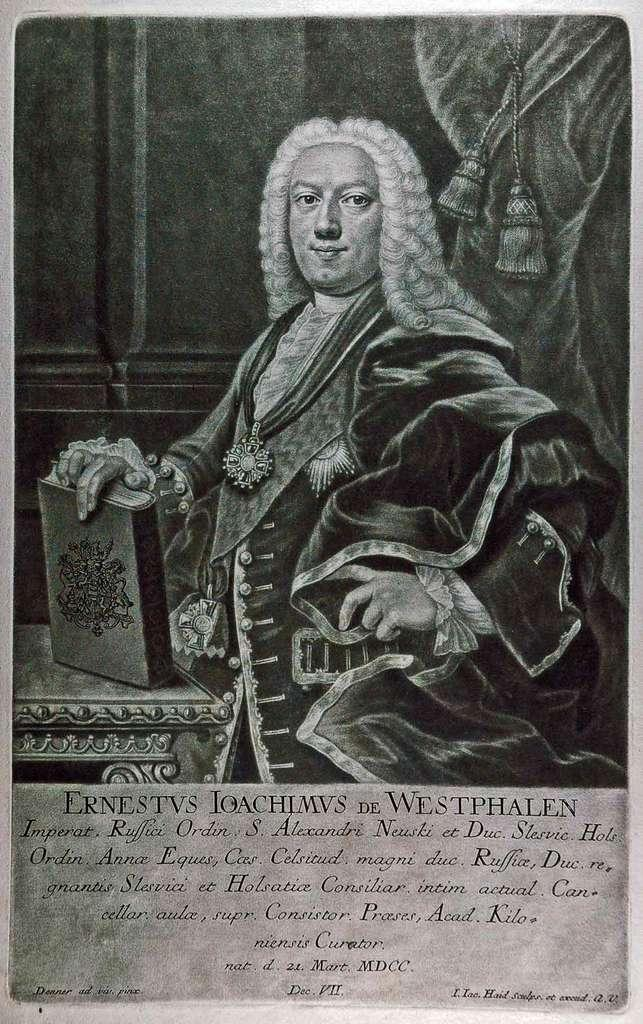What is the main subject of the image? There is a picture of a man in the image. What is the man holding in the picture? The man is holding a book in the picture. Can you describe any other elements in the image? There is written text in the image. How many pins can be seen in the image? There are no pins present in the image. What type of vein is visible in the image? There is no vein visible in the image. 